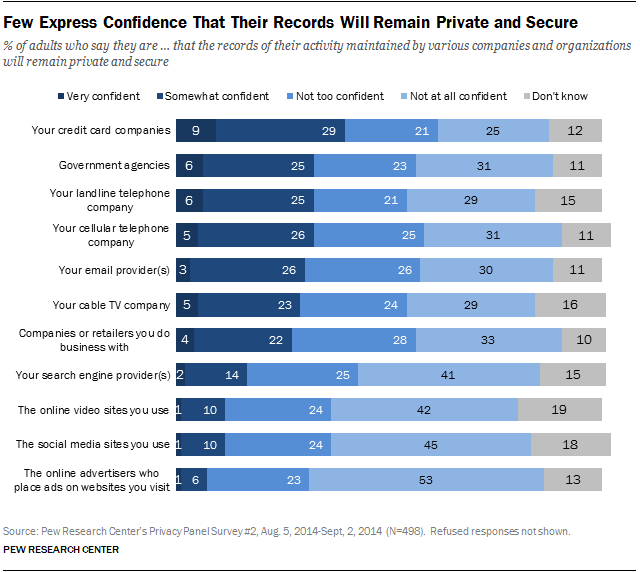Mention a couple of crucial points in this snapshot. The color of the rightmost bar in the group is gray. Among the top 3 bars, only 0.38% of adults are unsure if their data will be secure. 